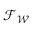<formula> <loc_0><loc_0><loc_500><loc_500>{ \mathcal { F } } _ { \mathcal { W } }</formula> 